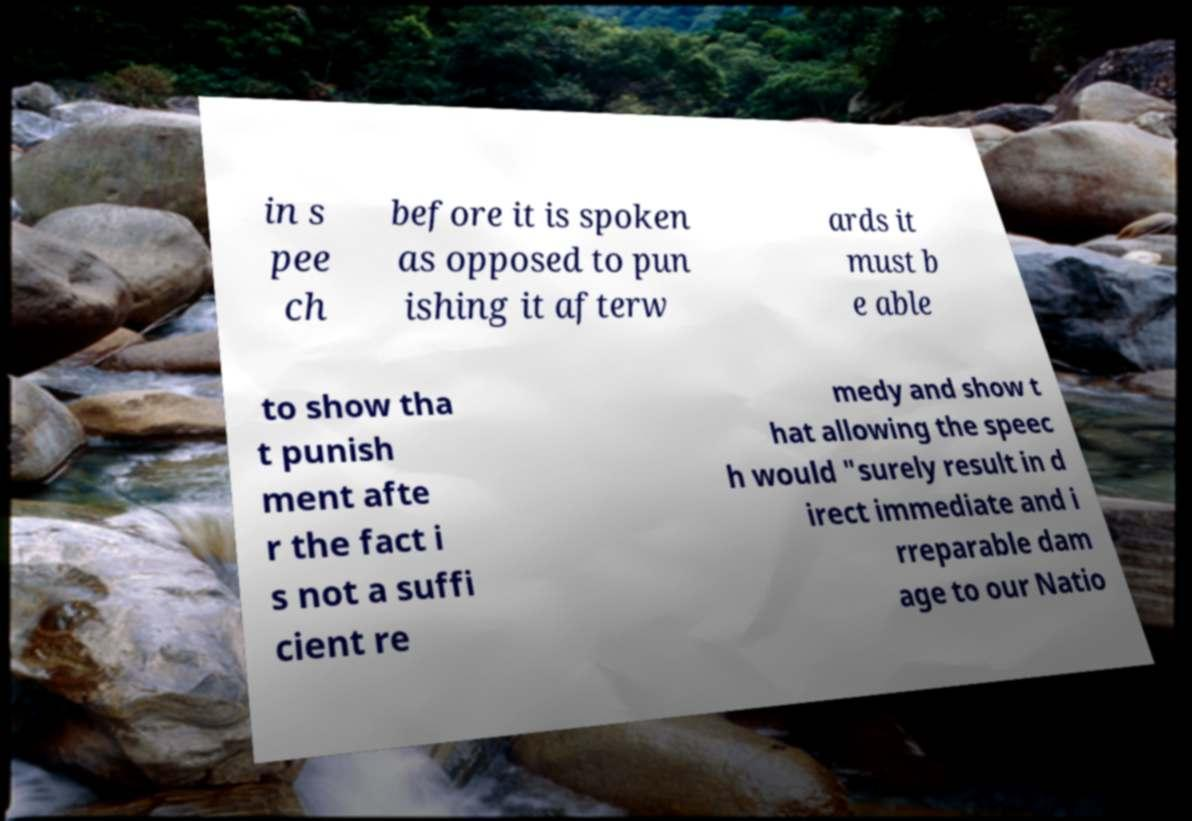Could you assist in decoding the text presented in this image and type it out clearly? in s pee ch before it is spoken as opposed to pun ishing it afterw ards it must b e able to show tha t punish ment afte r the fact i s not a suffi cient re medy and show t hat allowing the speec h would "surely result in d irect immediate and i rreparable dam age to our Natio 